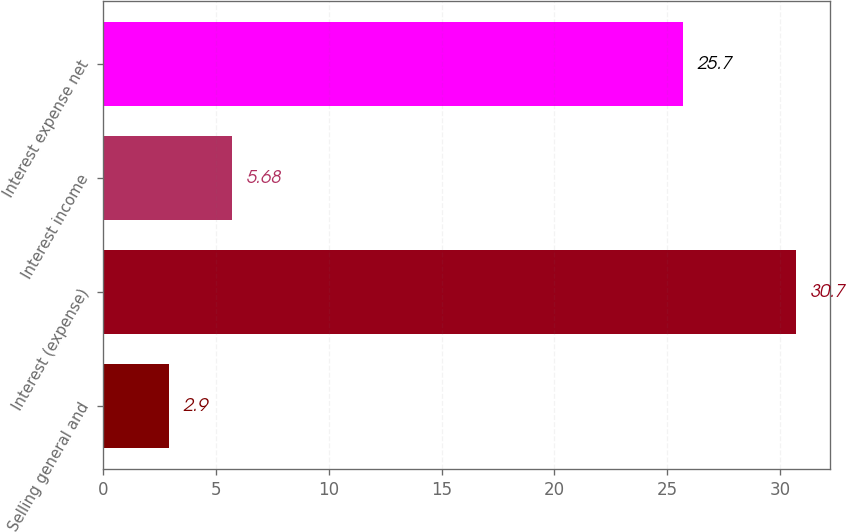Convert chart to OTSL. <chart><loc_0><loc_0><loc_500><loc_500><bar_chart><fcel>Selling general and<fcel>Interest (expense)<fcel>Interest income<fcel>Interest expense net<nl><fcel>2.9<fcel>30.7<fcel>5.68<fcel>25.7<nl></chart> 